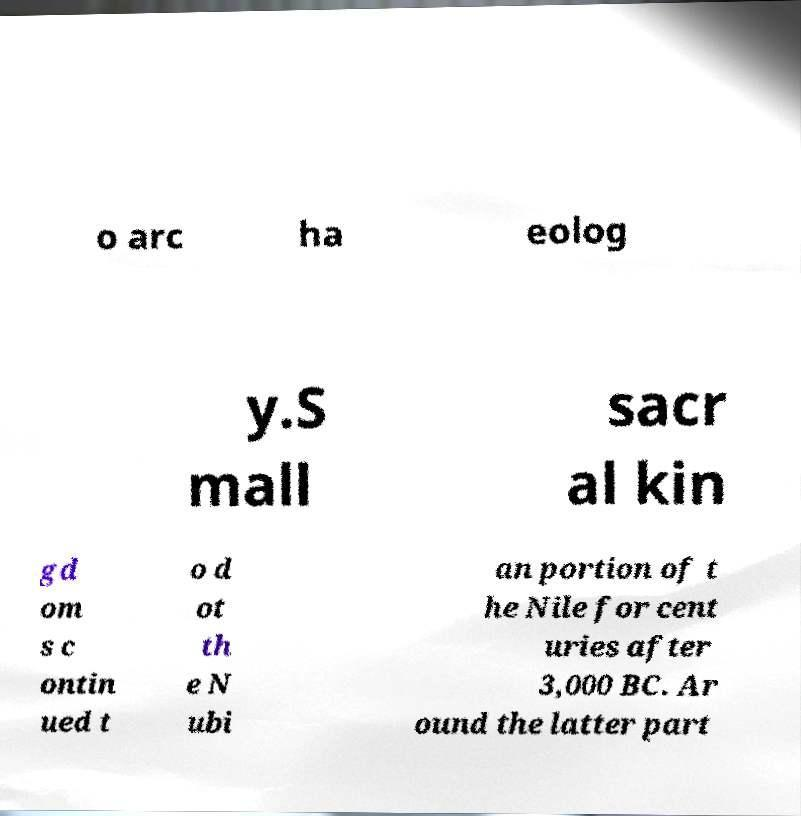Can you read and provide the text displayed in the image?This photo seems to have some interesting text. Can you extract and type it out for me? o arc ha eolog y.S mall sacr al kin gd om s c ontin ued t o d ot th e N ubi an portion of t he Nile for cent uries after 3,000 BC. Ar ound the latter part 